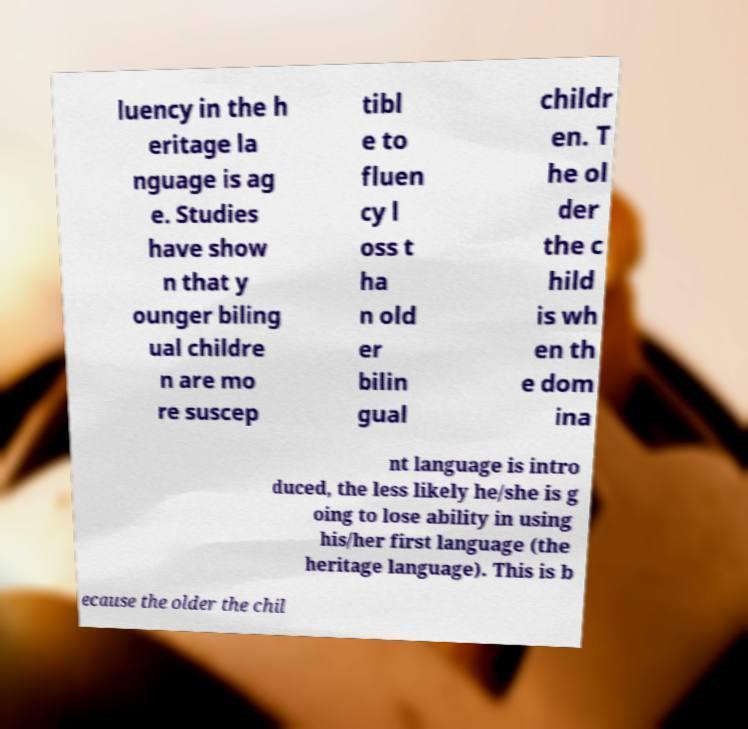Could you assist in decoding the text presented in this image and type it out clearly? luency in the h eritage la nguage is ag e. Studies have show n that y ounger biling ual childre n are mo re suscep tibl e to fluen cy l oss t ha n old er bilin gual childr en. T he ol der the c hild is wh en th e dom ina nt language is intro duced, the less likely he/she is g oing to lose ability in using his/her first language (the heritage language). This is b ecause the older the chil 